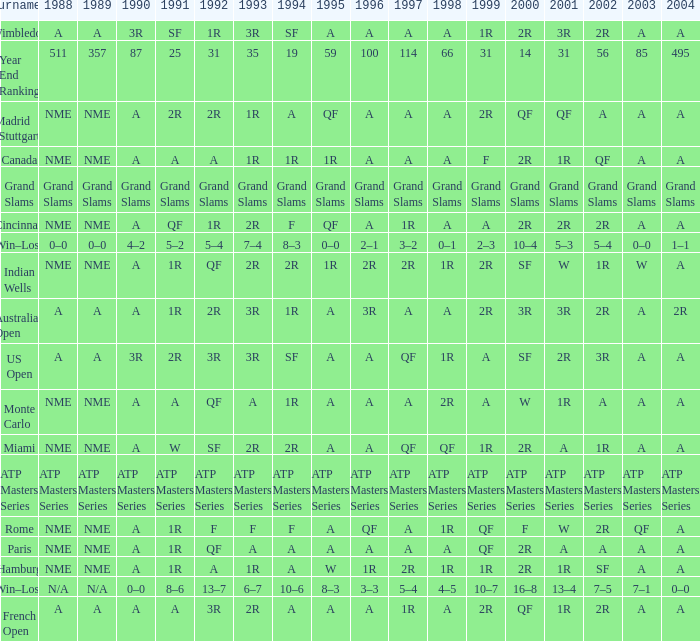What shows for 1992 when 1988 is A, at the Australian Open? 2R. 